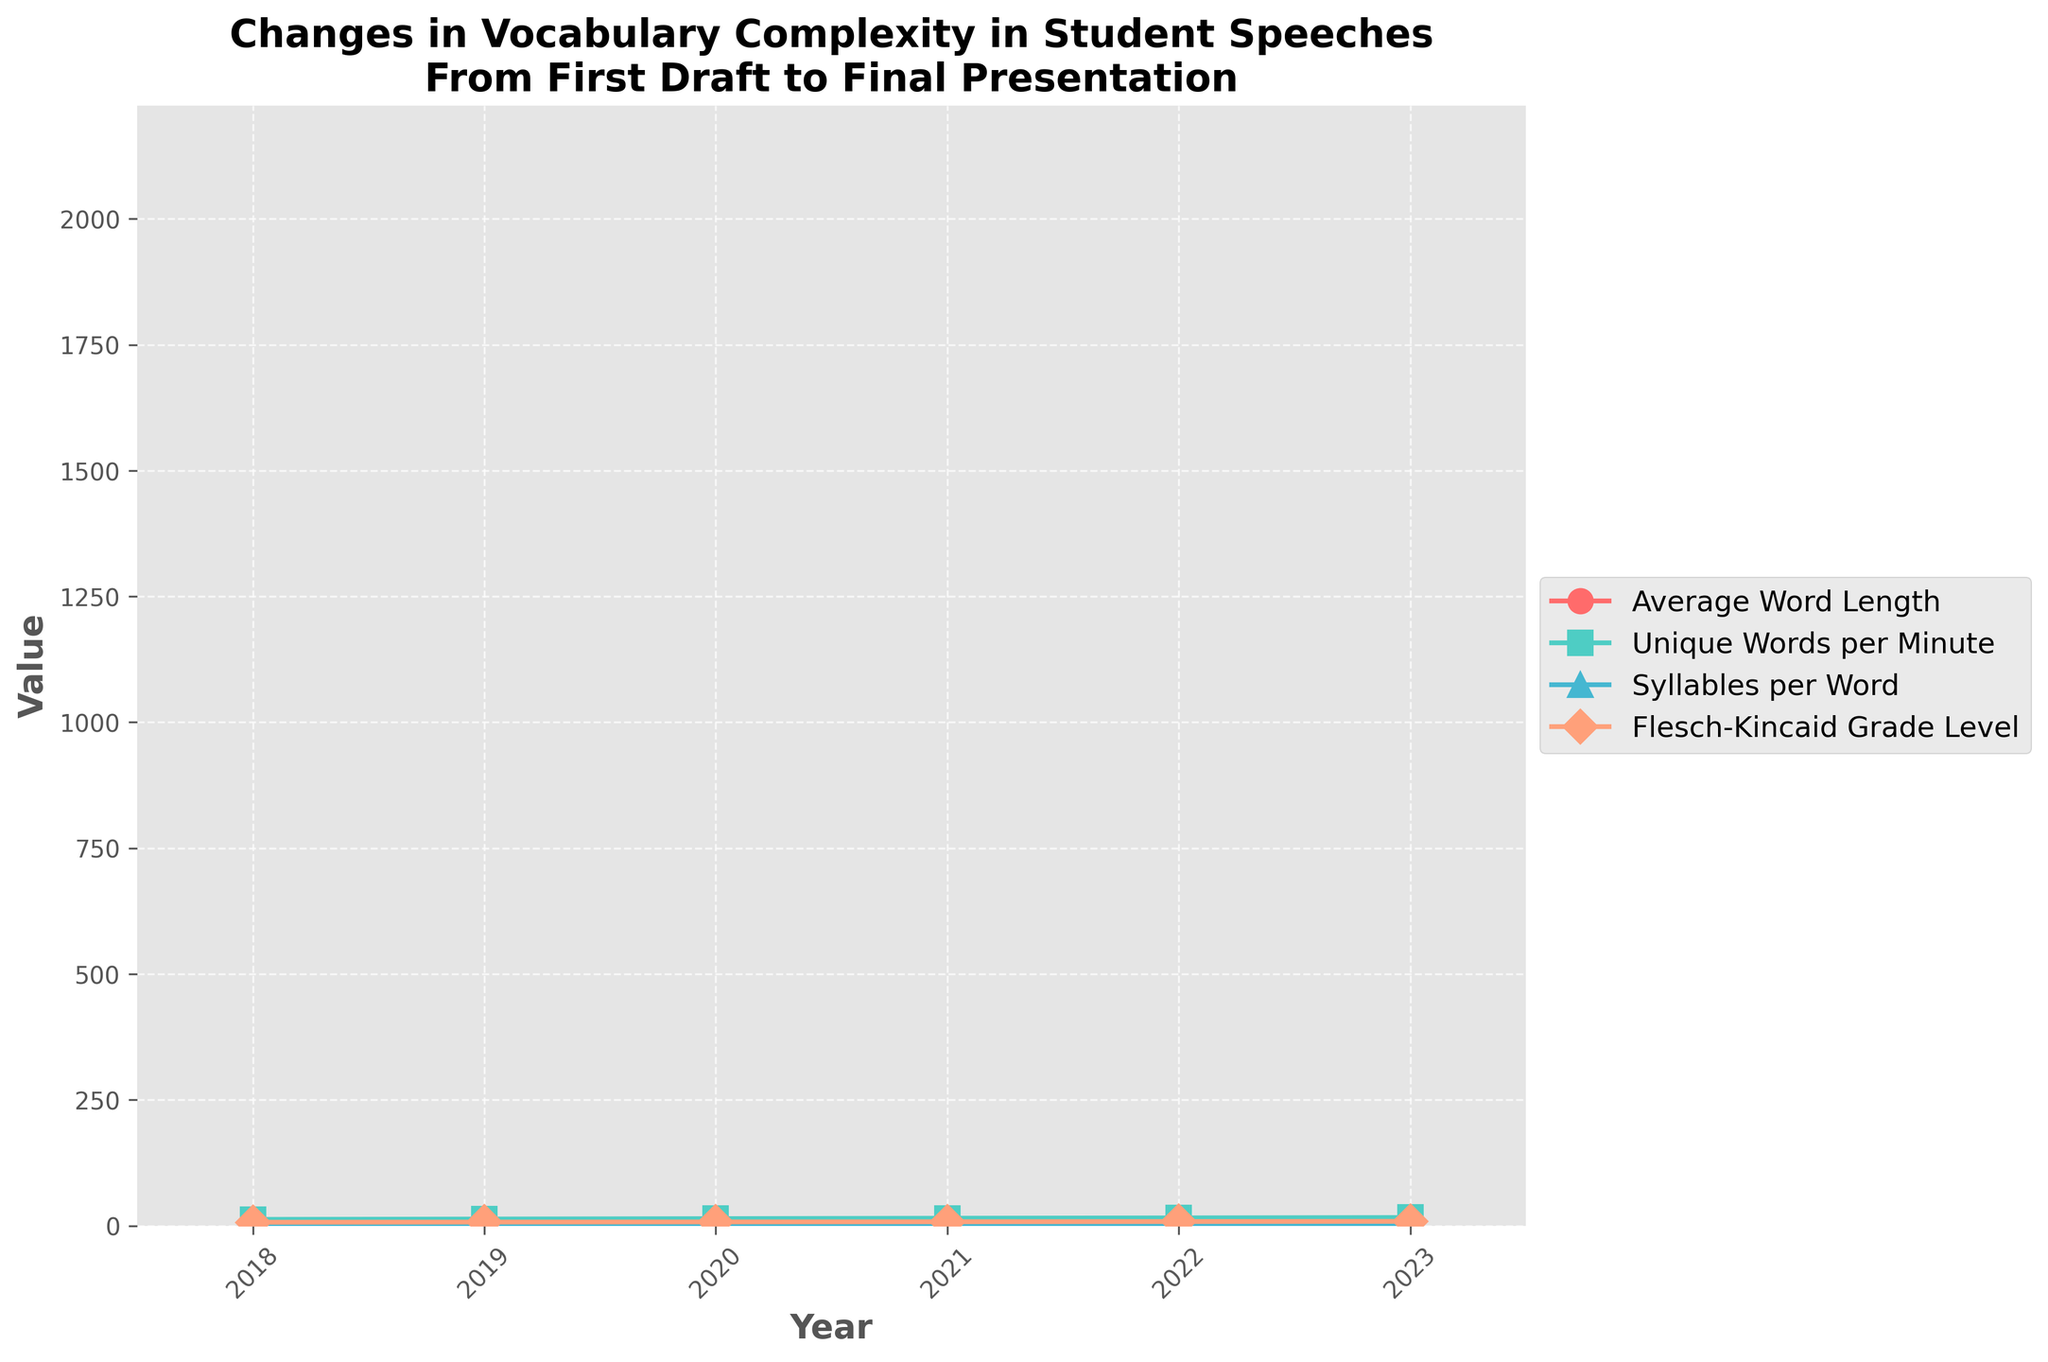What is the trend in Average Word Length from 2018 to 2023? The Average Word Length increases each year from 4.2 in 2018 to 5.1 in 2023, indicating a upward trend.
Answer: Increasing How many years are included in the plot? The x-axis shows the years from 2018 to 2023. By counting these years, we can see that there are 6 years included in the plot.
Answer: 6 Which metric increases the most between 2018 and 2023? By visually comparing the distance between the start and end points of each line, Flesch-Kincaid Grade Level shows the largest increase from 6.8 in 2018 to 8.7 in 2023.
Answer: Flesch-Kincaid Grade Level What was the Unique Words per Minute in 2021? Find the value on the green line with 's' markers at the year 2021. It shows Unique Words per Minute is 14.8.
Answer: 14.8 Compare the Syllables per Word in 2019 and 2022. Which year had a higher value? The value for Syllables per Word in 2019 was 1.4, while in 2022 it was 1.7. Thus, the value in 2022 is higher.
Answer: 2022 What is the difference in Average Word Length between 2018 and 2023? The Average Word Length in 2018 was 4.2, and in 2023 it was 5.1. The difference is 5.1 - 4.2 = 0.9.
Answer: 0.9 Which metric is represented by the red color in the plot? By looking at the legend, the red line corresponds to Average Word Length.
Answer: Average Word Length Is there any metric that does not show an upward trend over the years? All four metrics lines increase from 2018 to 2023. Hence, no metric shows a downward or constant trend.
Answer: No What are the values of the Flesch-Kincaid Grade Level for 2018 and 2020, and what is their sum? The Flesch-Kincaid Grade Level is 6.8 in 2018 and 7.5 in 2020. The sum is 6.8 + 7.5 = 14.3.
Answer: 14.3 Which year does Unique Words per Minute surpass 15 for the first time? Refer to the green line with 's' markers and find the first point where Unique Words per Minute surpasses 15, which is in the year 2022.
Answer: 2022 